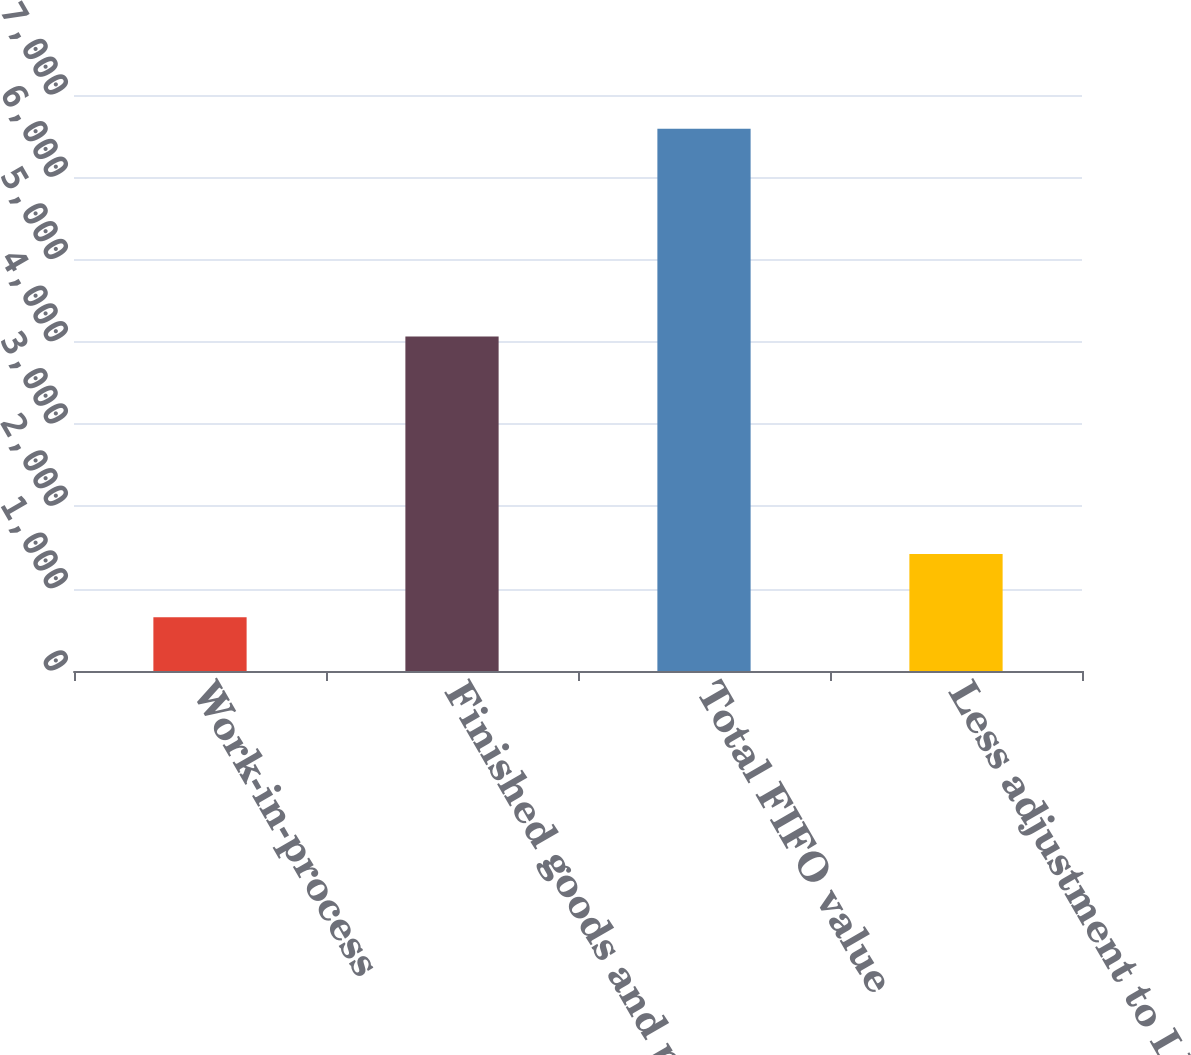Convert chart to OTSL. <chart><loc_0><loc_0><loc_500><loc_500><bar_chart><fcel>Work-in-process<fcel>Finished goods and parts<fcel>Total FIFO value<fcel>Less adjustment to LIFO value<nl><fcel>652<fcel>4065<fcel>6591<fcel>1421<nl></chart> 